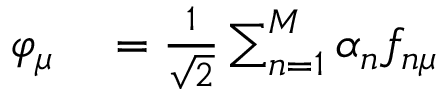Convert formula to latex. <formula><loc_0><loc_0><loc_500><loc_500>\begin{array} { r l } { \varphi _ { \mu } } & = \frac { 1 } { \sqrt { 2 } } \sum _ { n = 1 } ^ { M } \alpha _ { n } f _ { n \mu } } \end{array}</formula> 